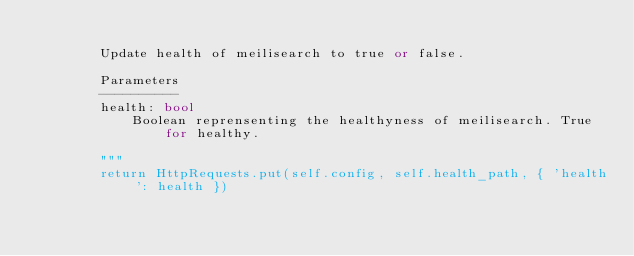<code> <loc_0><loc_0><loc_500><loc_500><_Python_>
        Update health of meilisearch to true or false.

        Parameters
        ----------
        health: bool
            Boolean reprensenting the healthyness of meilisearch. True for healthy.

        """
        return HttpRequests.put(self.config, self.health_path, { 'health': health })
</code> 